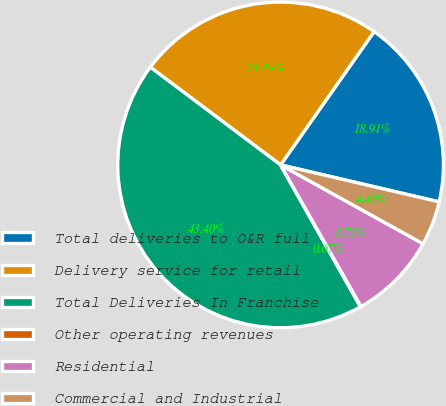<chart> <loc_0><loc_0><loc_500><loc_500><pie_chart><fcel>Total deliveries to O&R full<fcel>Delivery service for retail<fcel>Total Deliveries In Franchise<fcel>Other operating revenues<fcel>Residential<fcel>Commercial and Industrial<nl><fcel>18.91%<fcel>24.49%<fcel>43.4%<fcel>0.07%<fcel>8.73%<fcel>4.4%<nl></chart> 